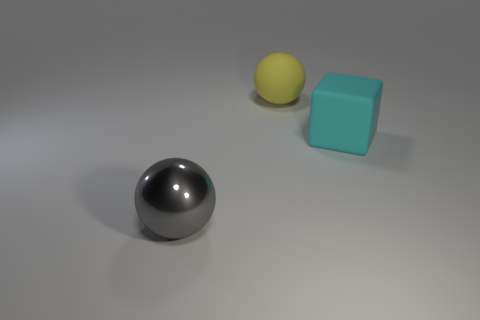Can you describe the texture differences between the objects? Certainly! The sphere is smooth with a reflective metallic surface, whereas the cube has a matte finish that diffuses light, indicating a non-reflective texture. 